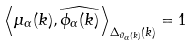Convert formula to latex. <formula><loc_0><loc_0><loc_500><loc_500>\left \langle \mu _ { \alpha } ( k ) , \widehat { \phi _ { \alpha } ( k ) } \right \rangle _ { \Delta _ { \vartheta _ { \alpha } ( k ) } ( k ) } = 1</formula> 